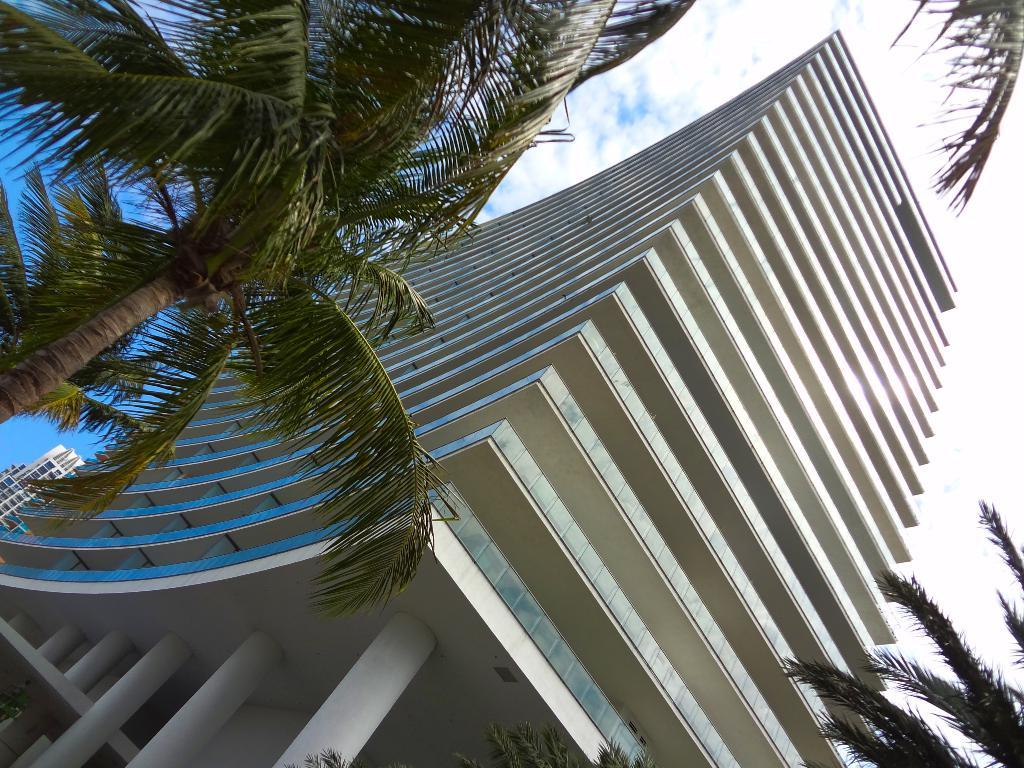What is the main structure in the middle of the image? There is a building in the middle of the image. What type of vegetation surrounds the building? There are trees on either side of the building. What can be seen above the building? The sky is visible above the building. What is present in the sky? Clouds are present in the sky. What type of glue is being used to hold the agreement together in the image? There is no agreement or glue present in the image; it features a building with trees on either side and a sky with clouds. 